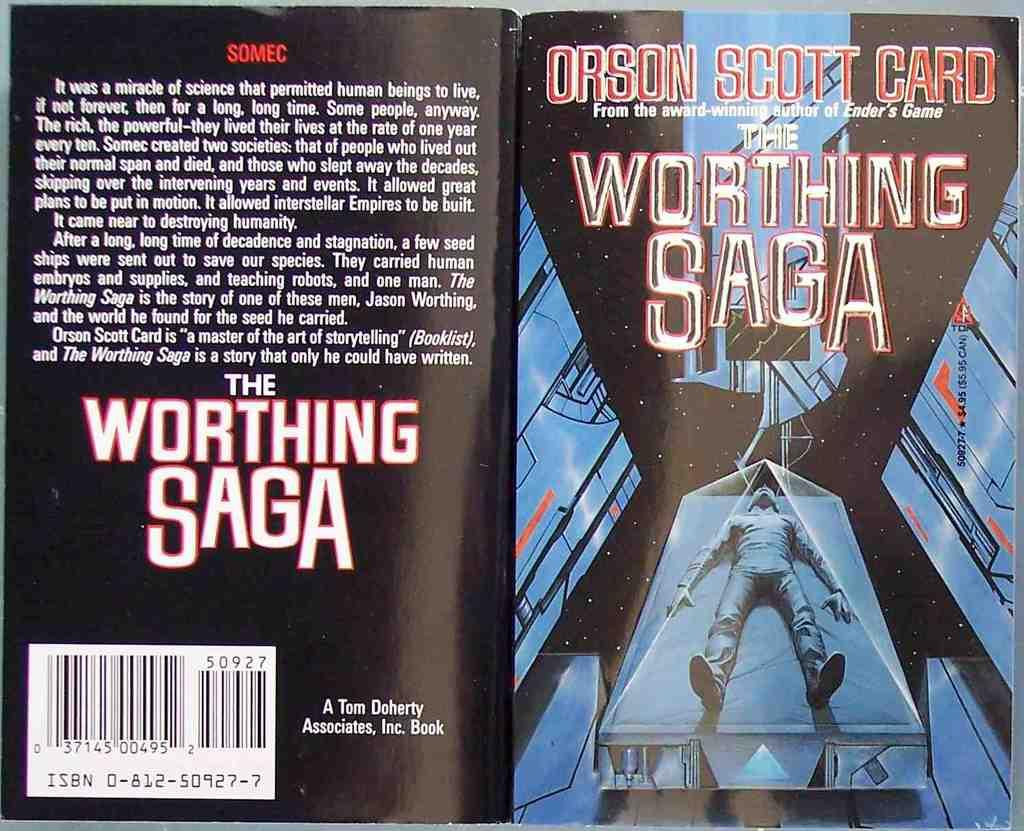<image>
Share a concise interpretation of the image provided. The working saga a book by Orson Scott Card. 